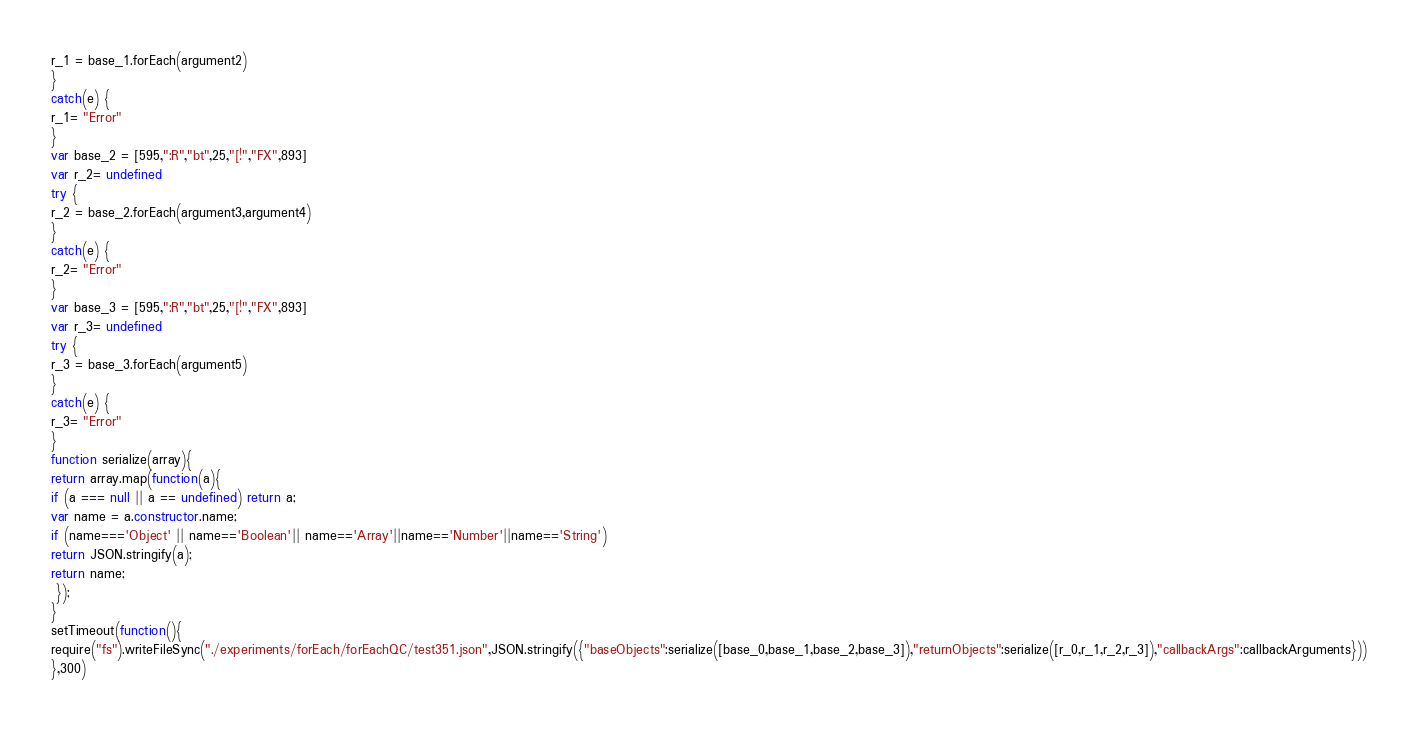Convert code to text. <code><loc_0><loc_0><loc_500><loc_500><_JavaScript_>r_1 = base_1.forEach(argument2)
}
catch(e) {
r_1= "Error"
}
var base_2 = [595,":R","bt",25,"[!","FX",893]
var r_2= undefined
try {
r_2 = base_2.forEach(argument3,argument4)
}
catch(e) {
r_2= "Error"
}
var base_3 = [595,":R","bt",25,"[!","FX",893]
var r_3= undefined
try {
r_3 = base_3.forEach(argument5)
}
catch(e) {
r_3= "Error"
}
function serialize(array){
return array.map(function(a){
if (a === null || a == undefined) return a;
var name = a.constructor.name;
if (name==='Object' || name=='Boolean'|| name=='Array'||name=='Number'||name=='String')
return JSON.stringify(a);
return name;
 });
}
setTimeout(function(){
require("fs").writeFileSync("./experiments/forEach/forEachQC/test351.json",JSON.stringify({"baseObjects":serialize([base_0,base_1,base_2,base_3]),"returnObjects":serialize([r_0,r_1,r_2,r_3]),"callbackArgs":callbackArguments}))
},300)</code> 